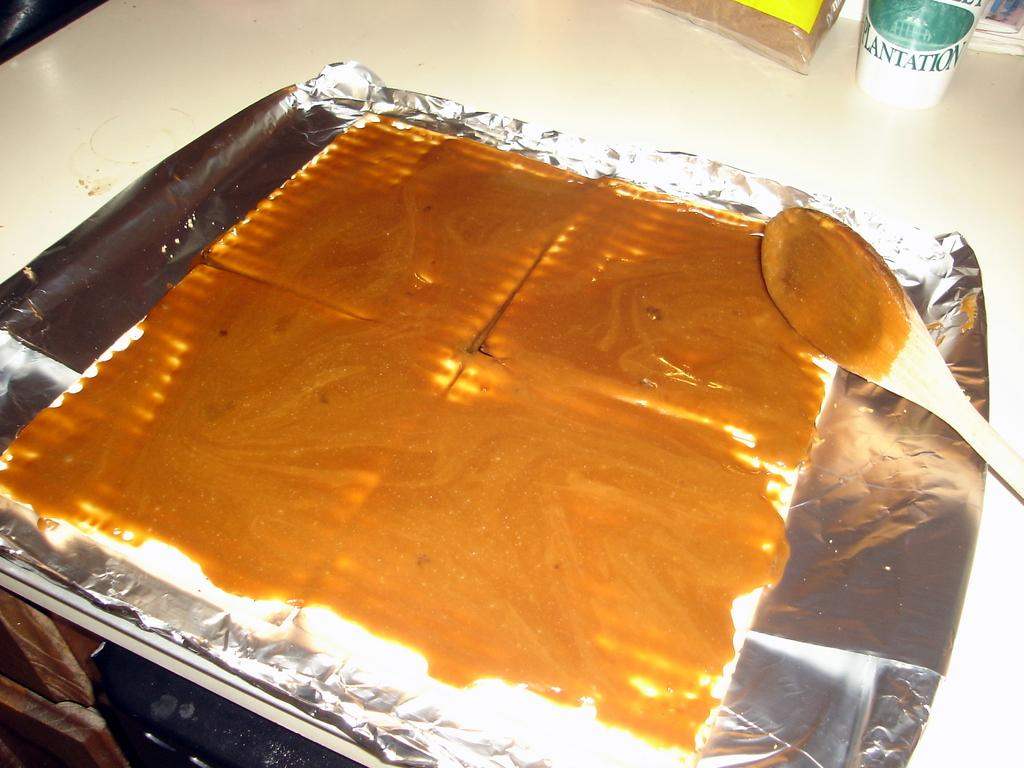<image>
Render a clear and concise summary of the photo. A cup with the word Plantation on it is on the back of a table behind some tinfoil. 